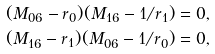Convert formula to latex. <formula><loc_0><loc_0><loc_500><loc_500>( M _ { 0 6 } - r _ { 0 } ) ( M _ { 1 6 } - 1 / r _ { 1 } ) = 0 , \\ ( M _ { 1 6 } - r _ { 1 } ) ( M _ { 0 6 } - 1 / r _ { 0 } ) = 0 ,</formula> 